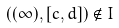<formula> <loc_0><loc_0><loc_500><loc_500>( ( \infty ) , [ c , d ] ) \notin I</formula> 